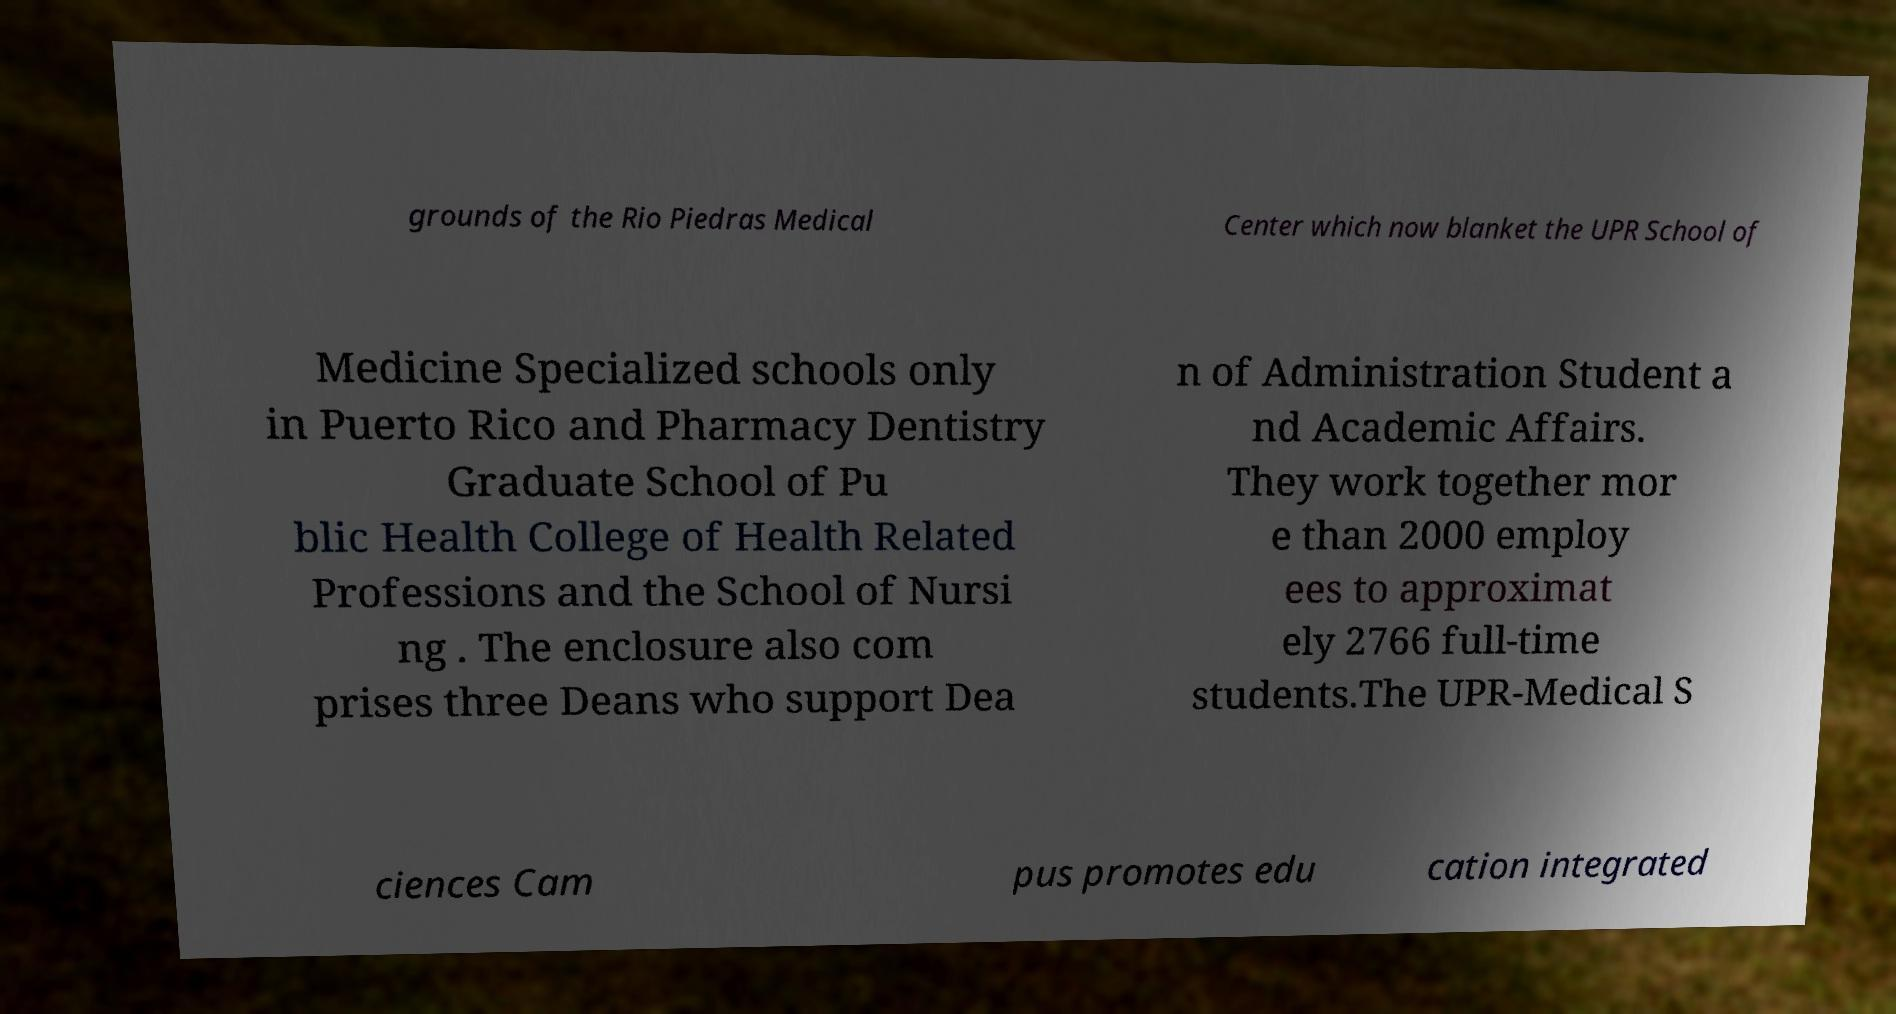Could you assist in decoding the text presented in this image and type it out clearly? grounds of the Rio Piedras Medical Center which now blanket the UPR School of Medicine Specialized schools only in Puerto Rico and Pharmacy Dentistry Graduate School of Pu blic Health College of Health Related Professions and the School of Nursi ng . The enclosure also com prises three Deans who support Dea n of Administration Student a nd Academic Affairs. They work together mor e than 2000 employ ees to approximat ely 2766 full-time students.The UPR-Medical S ciences Cam pus promotes edu cation integrated 